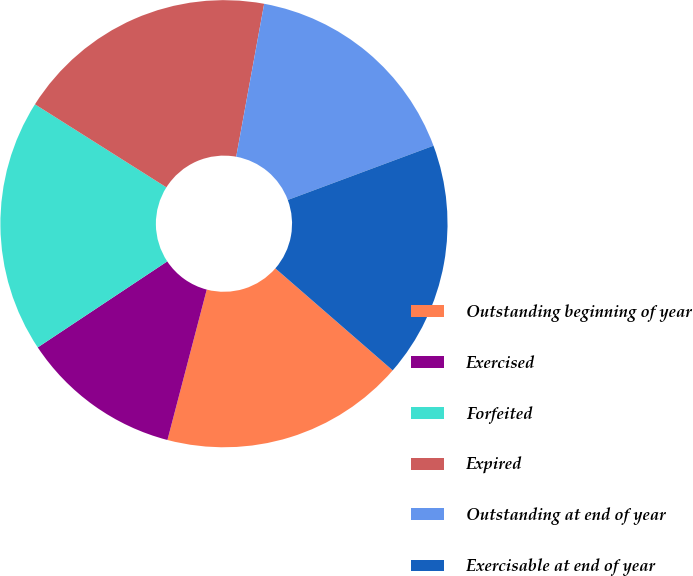<chart> <loc_0><loc_0><loc_500><loc_500><pie_chart><fcel>Outstanding beginning of year<fcel>Exercised<fcel>Forfeited<fcel>Expired<fcel>Outstanding at end of year<fcel>Exercisable at end of year<nl><fcel>17.68%<fcel>11.6%<fcel>18.3%<fcel>18.91%<fcel>16.45%<fcel>17.06%<nl></chart> 